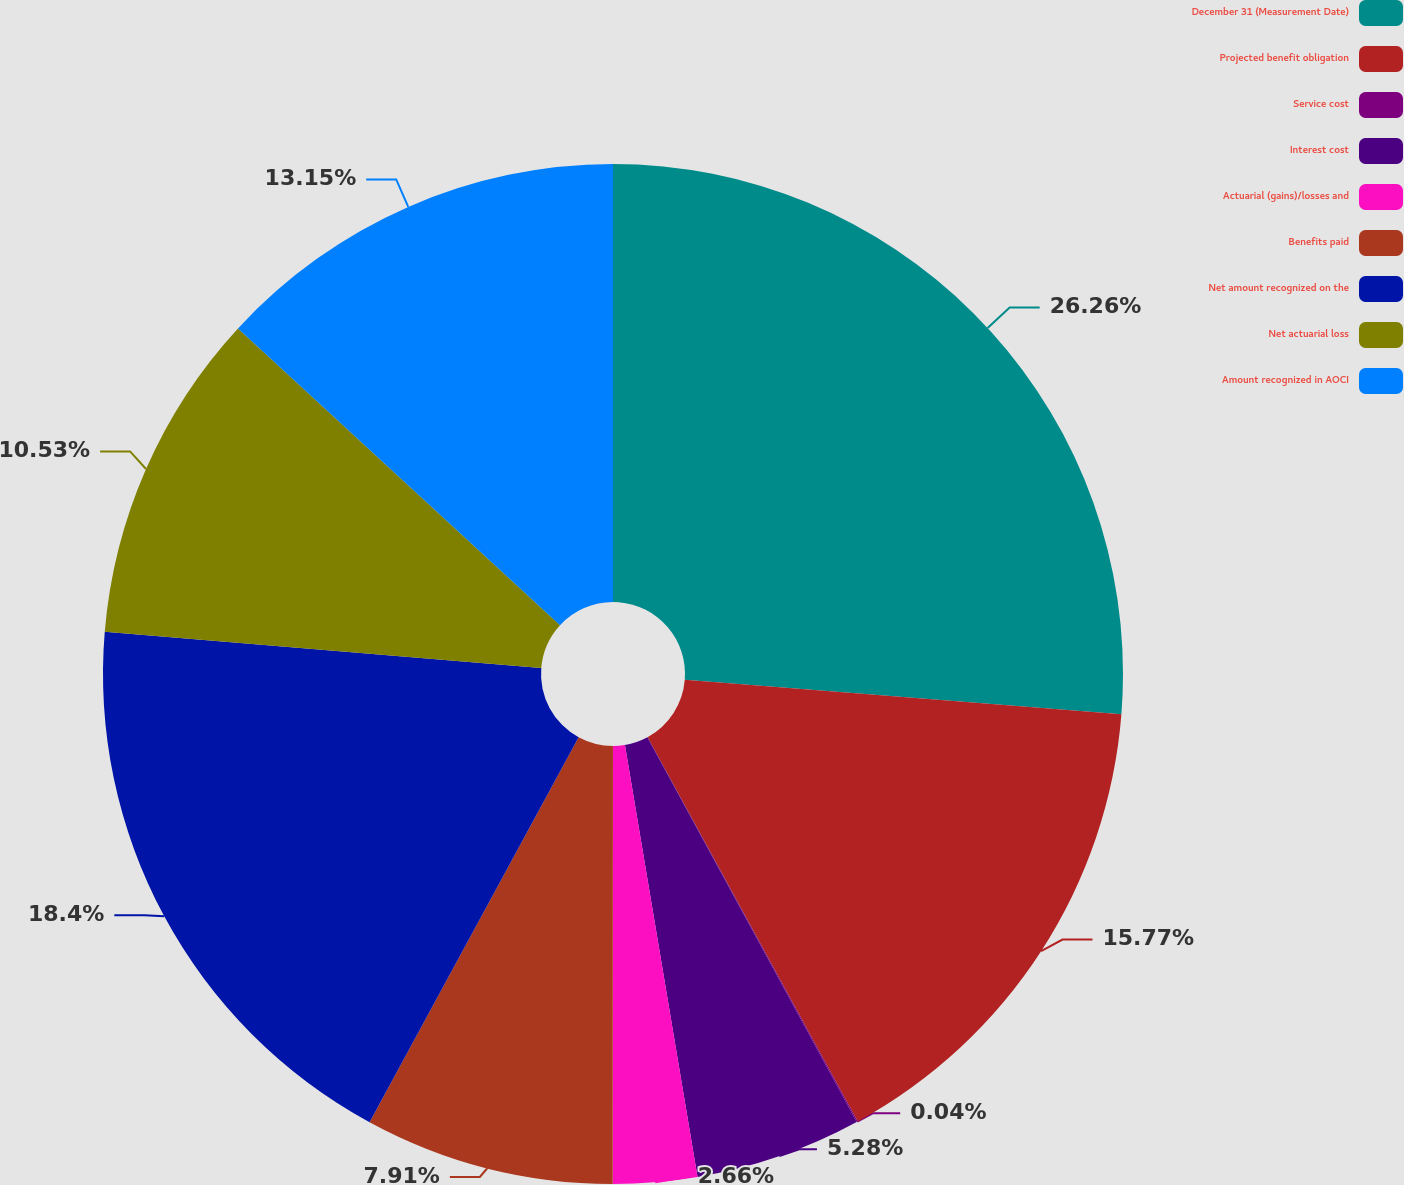<chart> <loc_0><loc_0><loc_500><loc_500><pie_chart><fcel>December 31 (Measurement Date)<fcel>Projected benefit obligation<fcel>Service cost<fcel>Interest cost<fcel>Actuarial (gains)/losses and<fcel>Benefits paid<fcel>Net amount recognized on the<fcel>Net actuarial loss<fcel>Amount recognized in AOCI<nl><fcel>26.26%<fcel>15.77%<fcel>0.04%<fcel>5.28%<fcel>2.66%<fcel>7.91%<fcel>18.4%<fcel>10.53%<fcel>13.15%<nl></chart> 